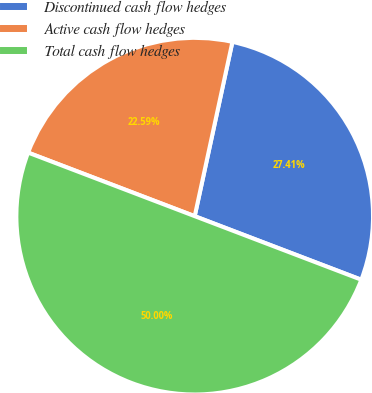<chart> <loc_0><loc_0><loc_500><loc_500><pie_chart><fcel>Discontinued cash flow hedges<fcel>Active cash flow hedges<fcel>Total cash flow hedges<nl><fcel>27.41%<fcel>22.59%<fcel>50.0%<nl></chart> 